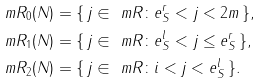Convert formula to latex. <formula><loc_0><loc_0><loc_500><loc_500>\ m R _ { 0 } ( N ) & = \{ \, j \in \ m R \colon e _ { S } ^ { r } < j < 2 m \, \} , \\ \ m R _ { 1 } ( N ) & = \{ \, j \in \ m R \colon e _ { S } ^ { l } < j \leq e _ { S } ^ { r } \, \} , \\ \ m R _ { 2 } ( N ) & = \{ \, j \in \ m R \colon i < j < e _ { S } ^ { l } \, \} .</formula> 